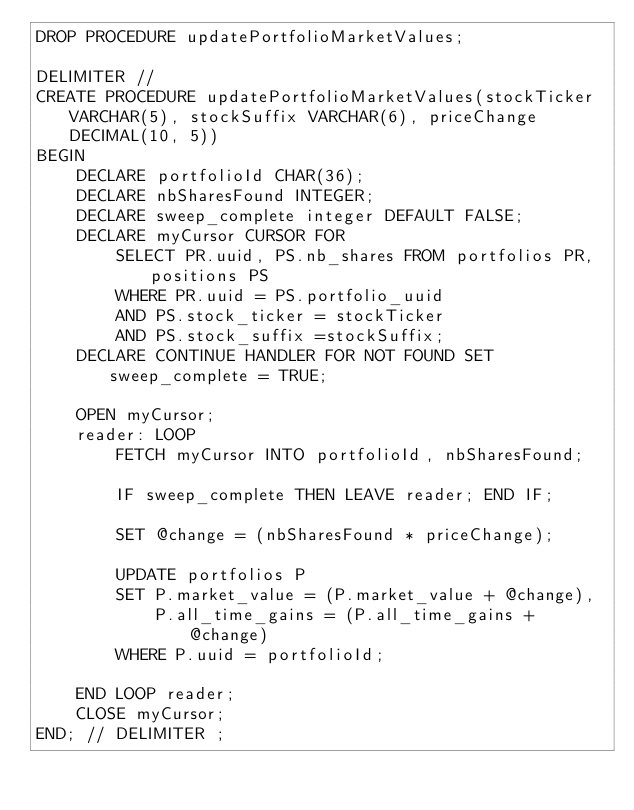<code> <loc_0><loc_0><loc_500><loc_500><_SQL_>DROP PROCEDURE updatePortfolioMarketValues;

DELIMITER //
CREATE PROCEDURE updatePortfolioMarketValues(stockTicker VARCHAR(5), stockSuffix VARCHAR(6), priceChange DECIMAL(10, 5))
BEGIN
    DECLARE portfolioId CHAR(36);
    DECLARE nbSharesFound INTEGER;
    DECLARE sweep_complete integer DEFAULT FALSE;
    DECLARE myCursor CURSOR FOR
        SELECT PR.uuid, PS.nb_shares FROM portfolios PR, positions PS
        WHERE PR.uuid = PS.portfolio_uuid
        AND PS.stock_ticker = stockTicker
        AND PS.stock_suffix =stockSuffix;
    DECLARE CONTINUE HANDLER FOR NOT FOUND SET sweep_complete = TRUE;

    OPEN myCursor;
    reader: LOOP
        FETCH myCursor INTO portfolioId, nbSharesFound;

        IF sweep_complete THEN LEAVE reader; END IF;

        SET @change = (nbSharesFound * priceChange);

        UPDATE portfolios P
        SET P.market_value = (P.market_value + @change),
            P.all_time_gains = (P.all_time_gains + @change)
        WHERE P.uuid = portfolioId;

    END LOOP reader;
    CLOSE myCursor;
END; // DELIMITER ;</code> 